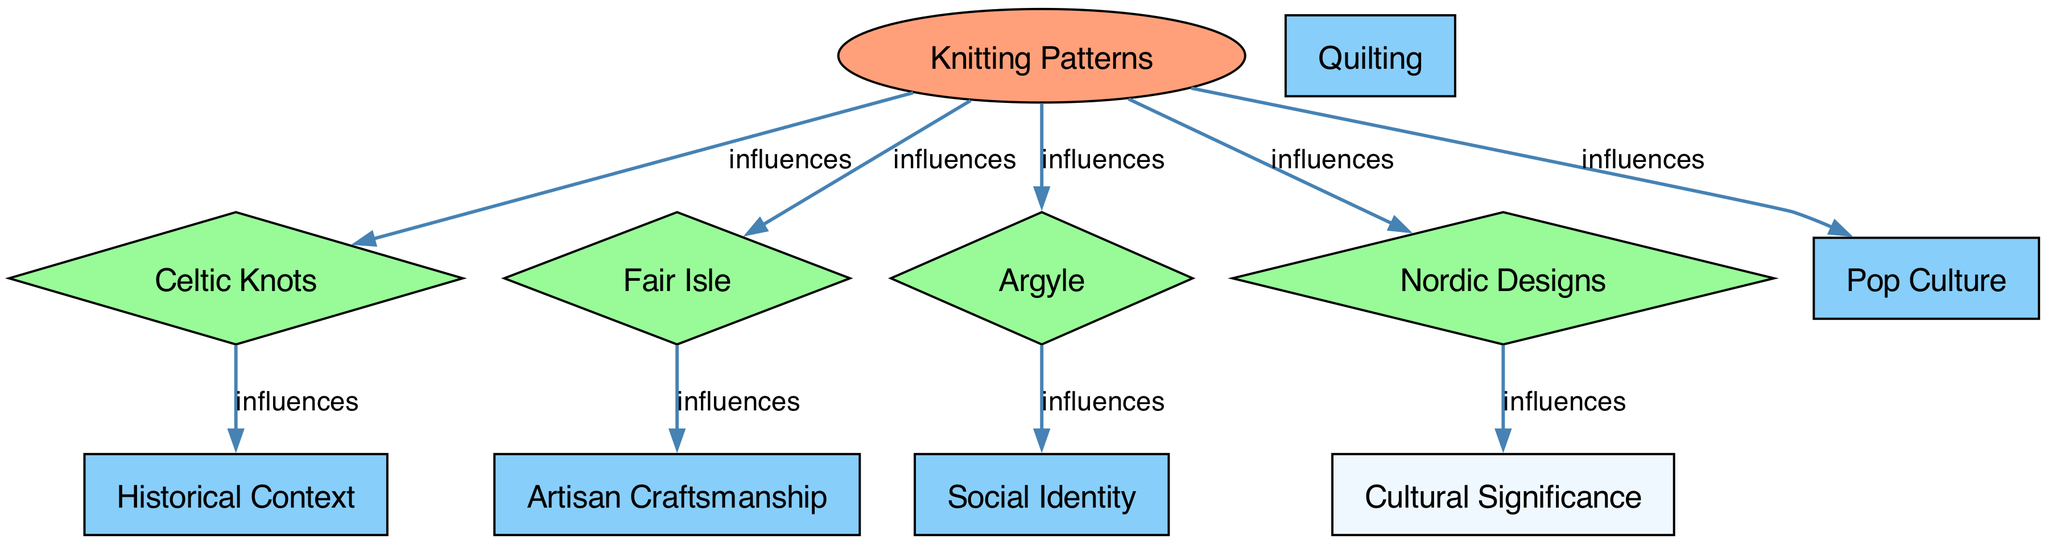What are the main categories of knitting patterns indicated in the diagram? The diagram shows four main categories of knitting patterns: Celtic Knots, Fair Isle, Argyle, and Nordic Designs, branching from the central node "Knitting Patterns."
Answer: Celtic Knots, Fair Isle, Argyle, Nordic Designs Which pattern influences social identity? The edge from "Argyle" to "Social Identity" indicates that Argyle influences Social Identity in the diagram.
Answer: Argyle How many nodes are present in the diagram? The diagram consists of ten nodes in total: one main node for "Knitting Patterns" and nine connected nodes that include various patterns and concepts.
Answer: Ten What relationship do Fair Isle patterns have with artisan craftsmanship? The diagram shows a direct influence where "Fair Isle" points to "Artisan Craftsmanship," indicating that Fair Isle patterns influence this aspect.
Answer: Influences Name one historical context linked to Celtic Knots. The diagram connects "Celtic Knots" to "Historical Context," showing that there is a link without specifying the exact context.
Answer: Historical Context Which knitting pattern connects to cultural significance? "Nordic Designs" connects directly to "Cultural Significance," as indicated by the directed edge in the diagram.
Answer: Nordic Designs Is there a relationship between knitting patterns and pop culture? Yes, the diagram indicates a direct influence from "Knitting Patterns" to "Pop Culture," showing that knitting patterns have a role in pop culture.
Answer: Yes How many edges are there in the diagram? Counting the connections between nodes, there are eight edges that show the relationship between the nodes in the diagram.
Answer: Eight What is the shape of the node for "Knitting Patterns"? The "Knitting Patterns" node is shaped like an ellipse, as indicated by the visual attributes in the diagram.
Answer: Ellipse Which knitting pattern influences historical context? The edge shows that "Celtic Knots" influences "Historical Context" in the diagram.
Answer: Celtic Knots 